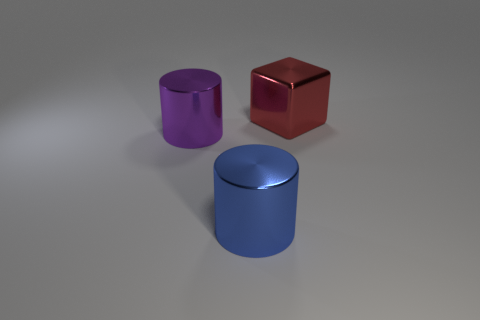Is the number of large metal cylinders that are in front of the big purple metallic object less than the number of things behind the big blue metallic object?
Offer a very short reply. Yes. What number of metal objects are behind the big purple metal cylinder?
Give a very brief answer. 1. Are there fewer big red cubes to the right of the metal block than blue things?
Your response must be concise. Yes. The large metal block is what color?
Offer a very short reply. Red. What color is the other big object that is the same shape as the large blue metallic thing?
Make the answer very short. Purple. What number of large things are either purple cylinders or red metal things?
Provide a short and direct response. 2. There is a metal thing left of the large blue metal thing; how big is it?
Provide a short and direct response. Large. Is there a big metallic object that has the same color as the cube?
Offer a terse response. No. There is a big cylinder that is on the left side of the big blue thing; what number of large blue shiny cylinders are to the left of it?
Make the answer very short. 0. How many large blue cylinders have the same material as the blue thing?
Provide a short and direct response. 0. 